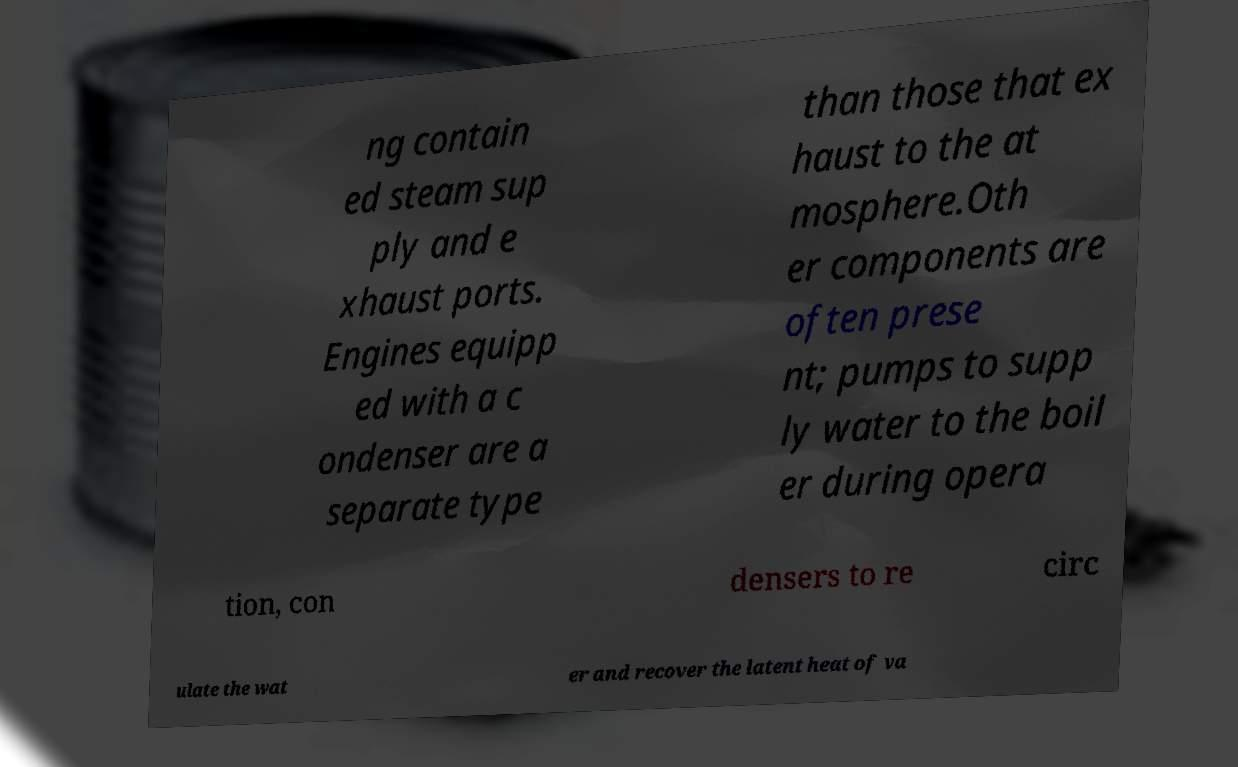Can you accurately transcribe the text from the provided image for me? ng contain ed steam sup ply and e xhaust ports. Engines equipp ed with a c ondenser are a separate type than those that ex haust to the at mosphere.Oth er components are often prese nt; pumps to supp ly water to the boil er during opera tion, con densers to re circ ulate the wat er and recover the latent heat of va 